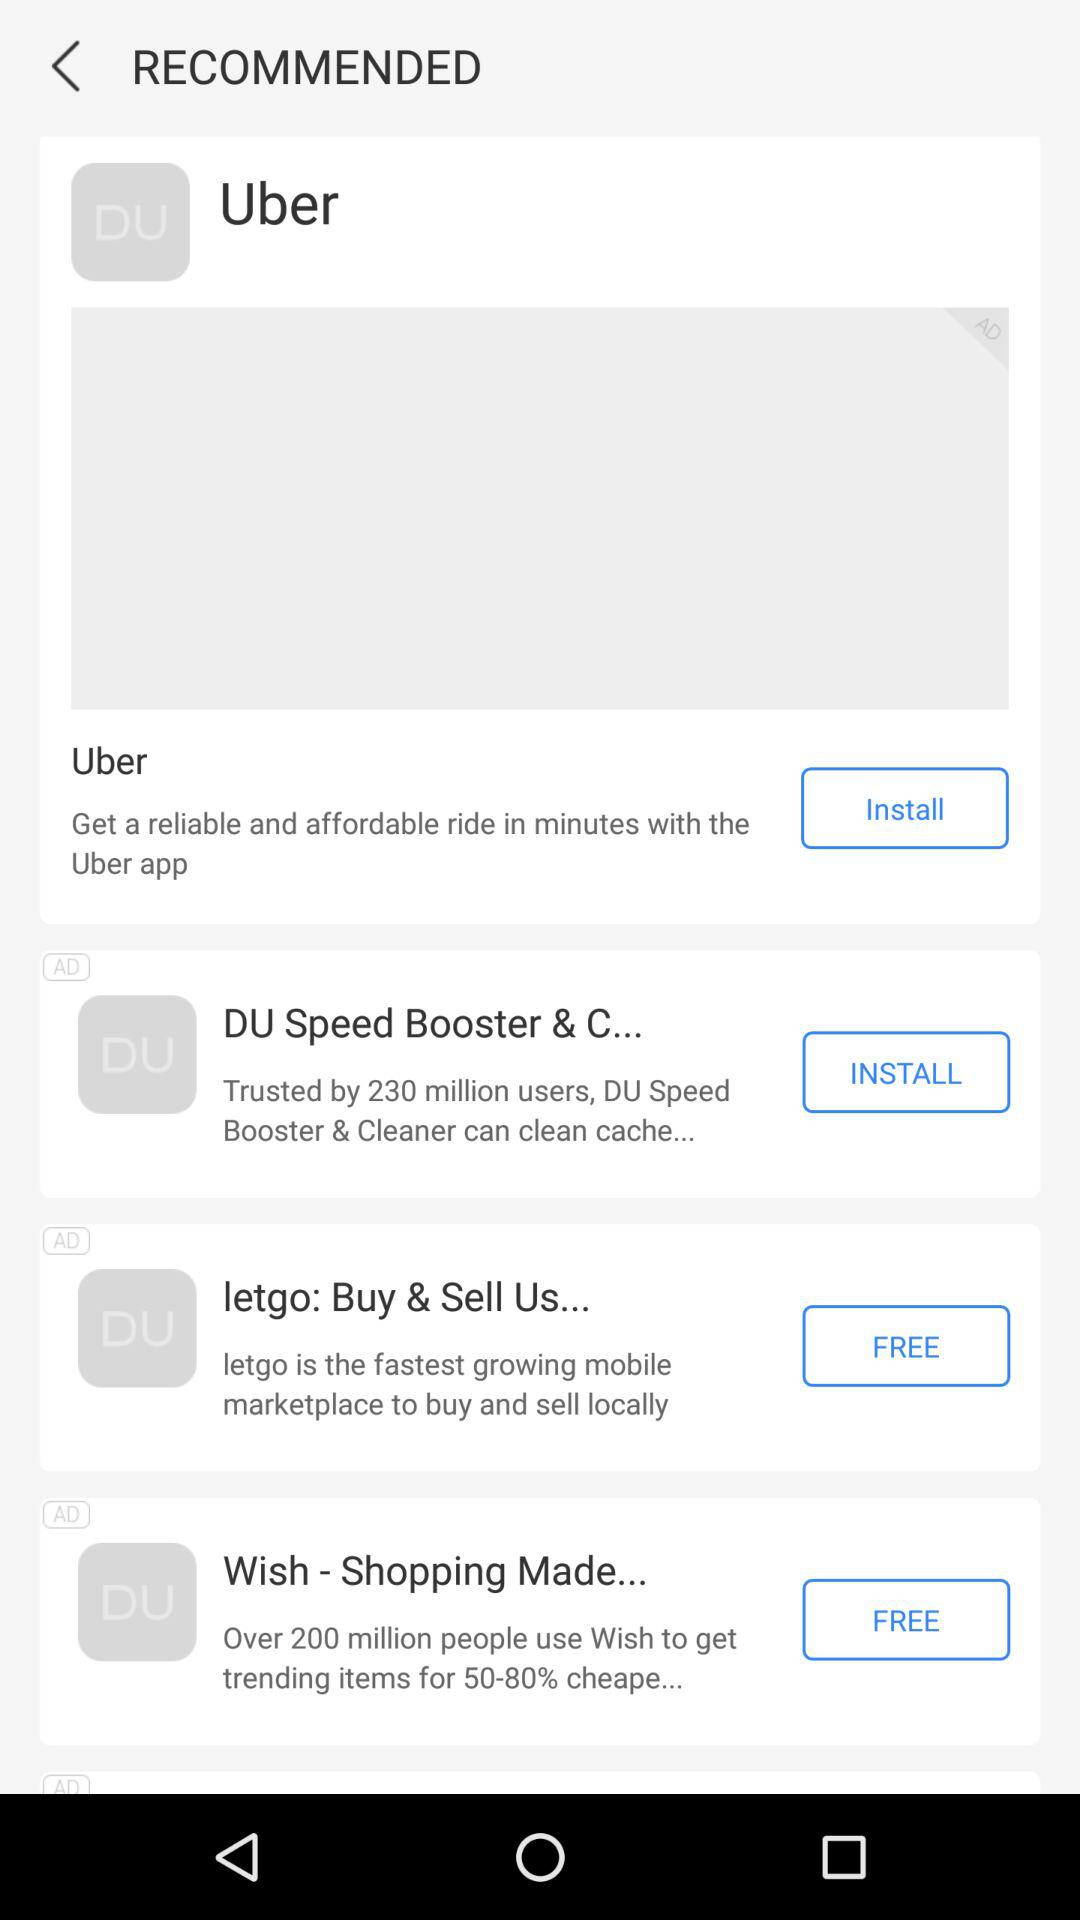How many recommended apps are there?
Answer the question using a single word or phrase. 4 